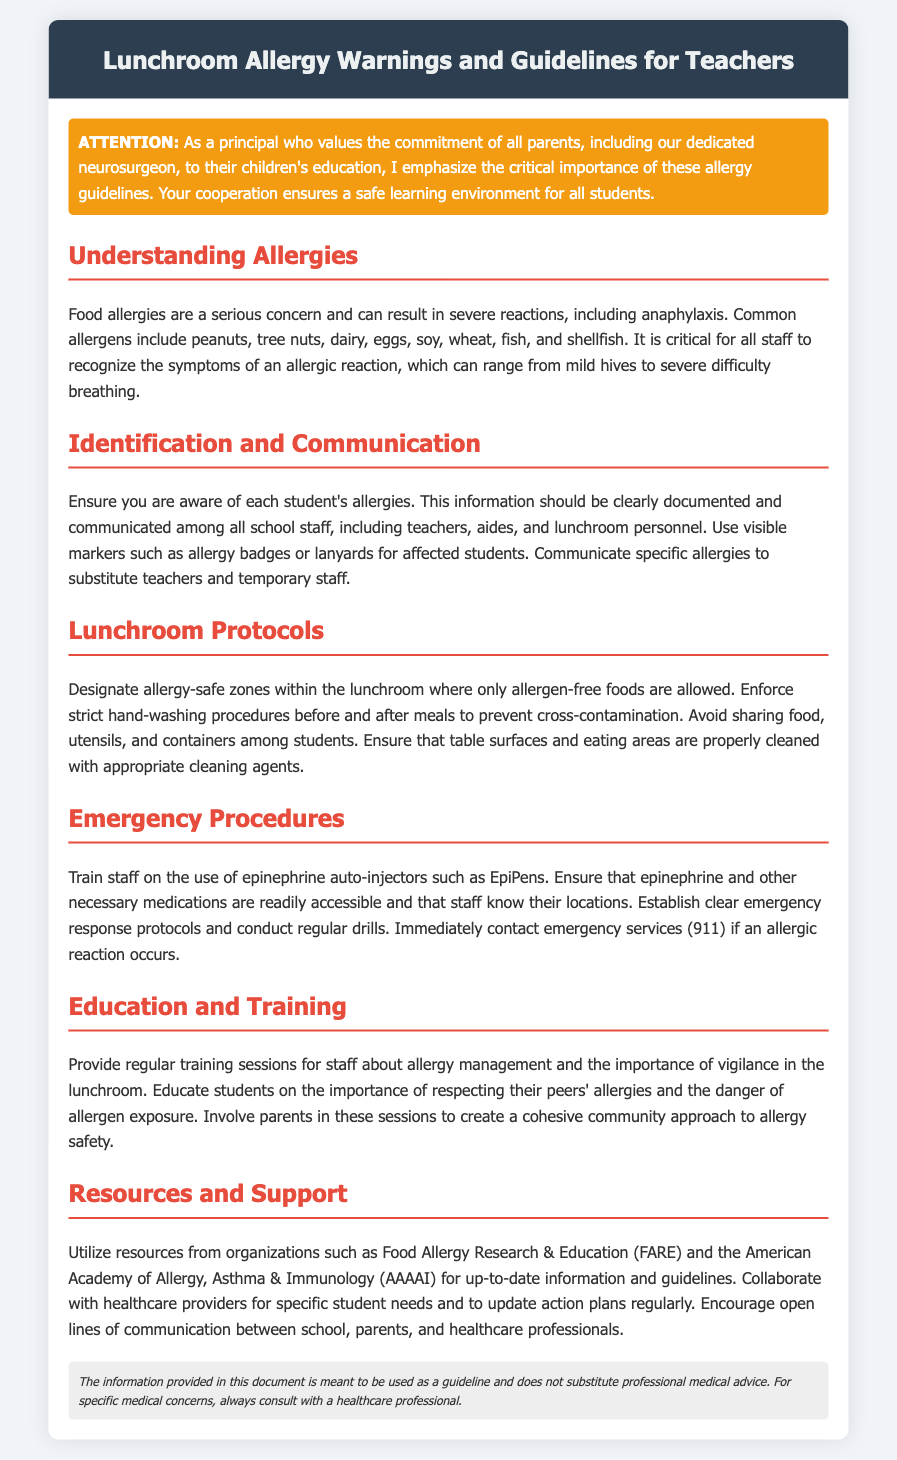What are common allergens? The document lists common allergens that include peanuts, tree nuts, dairy, eggs, soy, wheat, fish, and shellfish.
Answer: Peanuts, tree nuts, dairy, eggs, soy, wheat, fish, shellfish What should students use to identify allergies? It is recommended that students use visible markers such as allergy badges or lanyards to indicate their allergies.
Answer: Allergy badges or lanyards What is the first action to take in an emergency? The first response in the case of an allergic reaction is to immediately contact emergency services (911).
Answer: 911 How should food sharing be handled in the lunchroom? The document states that food sharing should be avoided among students to prevent allergen exposure.
Answer: Avoid sharing food What organization is mentioned for allergy resources? The document references Food Allergy Research & Education (FARE) as a resource for allergy information.
Answer: Food Allergy Research & Education (FARE) What training is recommended for staff? Regular training sessions for staff about allergy management and vigilance in the lunchroom are recommended.
Answer: Regular training sessions What is the purpose of the disclaimer? The disclaimer explains that the information in the document is a guideline and not a substitute for professional medical advice.
Answer: Guidance, not medical advice What should be done before and after meals? The document emphasizes that strict hand-washing procedures should be enforced before and after meals.
Answer: Strict hand-washing procedures 